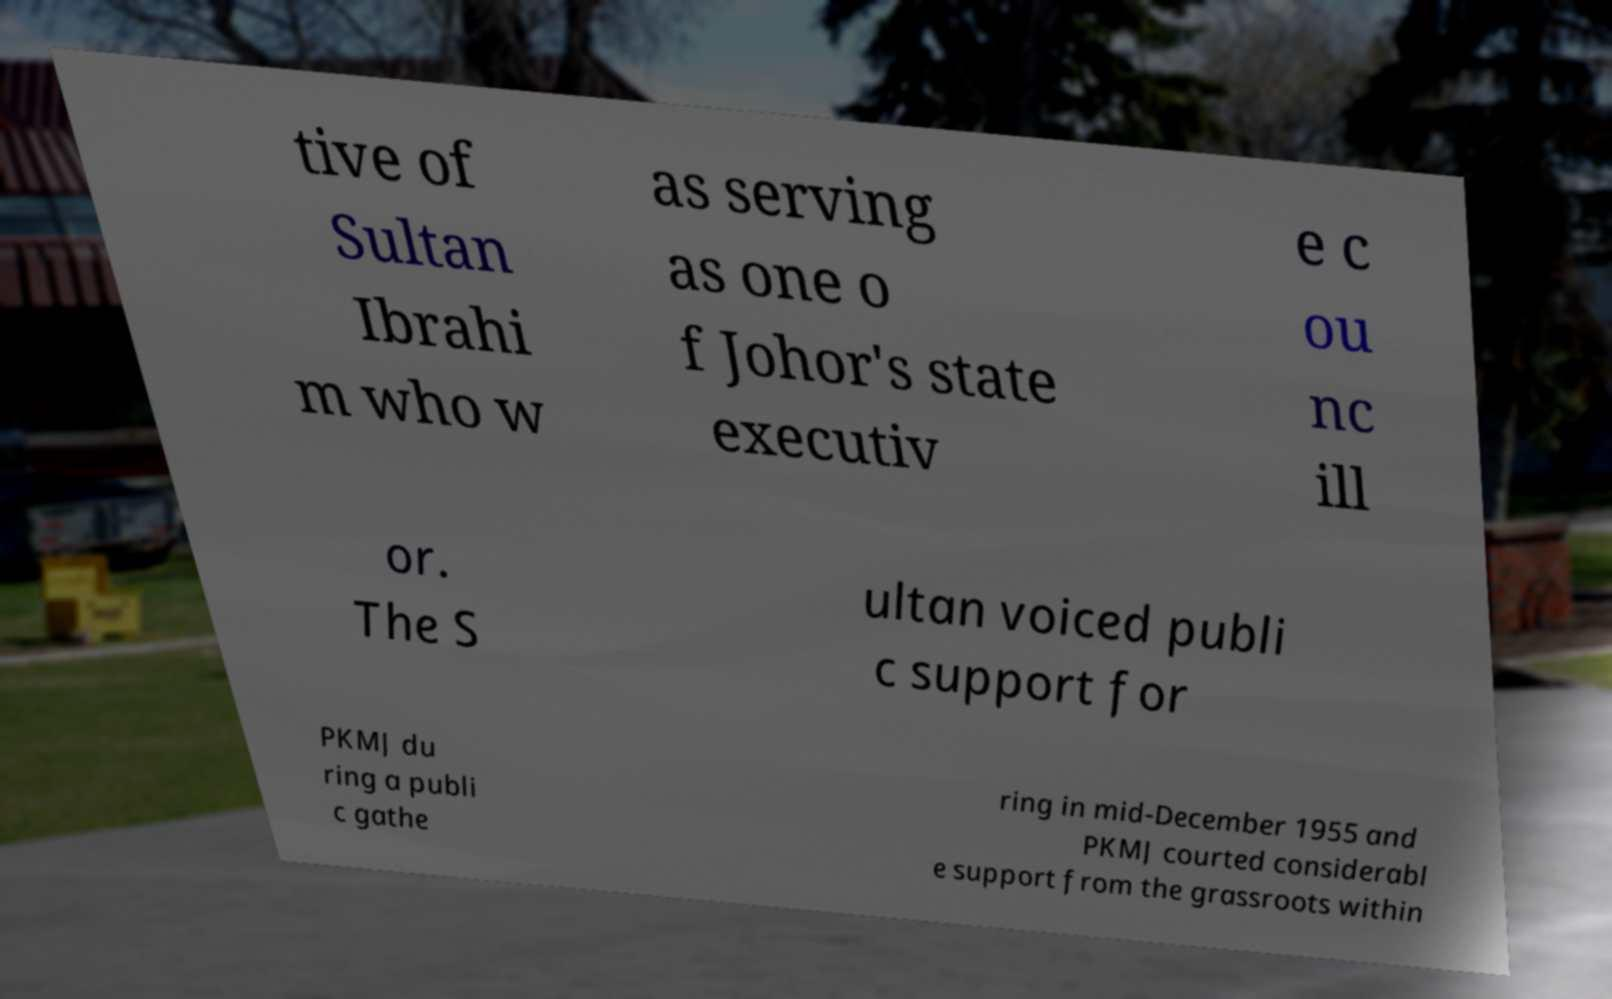Could you extract and type out the text from this image? tive of Sultan Ibrahi m who w as serving as one o f Johor's state executiv e c ou nc ill or. The S ultan voiced publi c support for PKMJ du ring a publi c gathe ring in mid-December 1955 and PKMJ courted considerabl e support from the grassroots within 